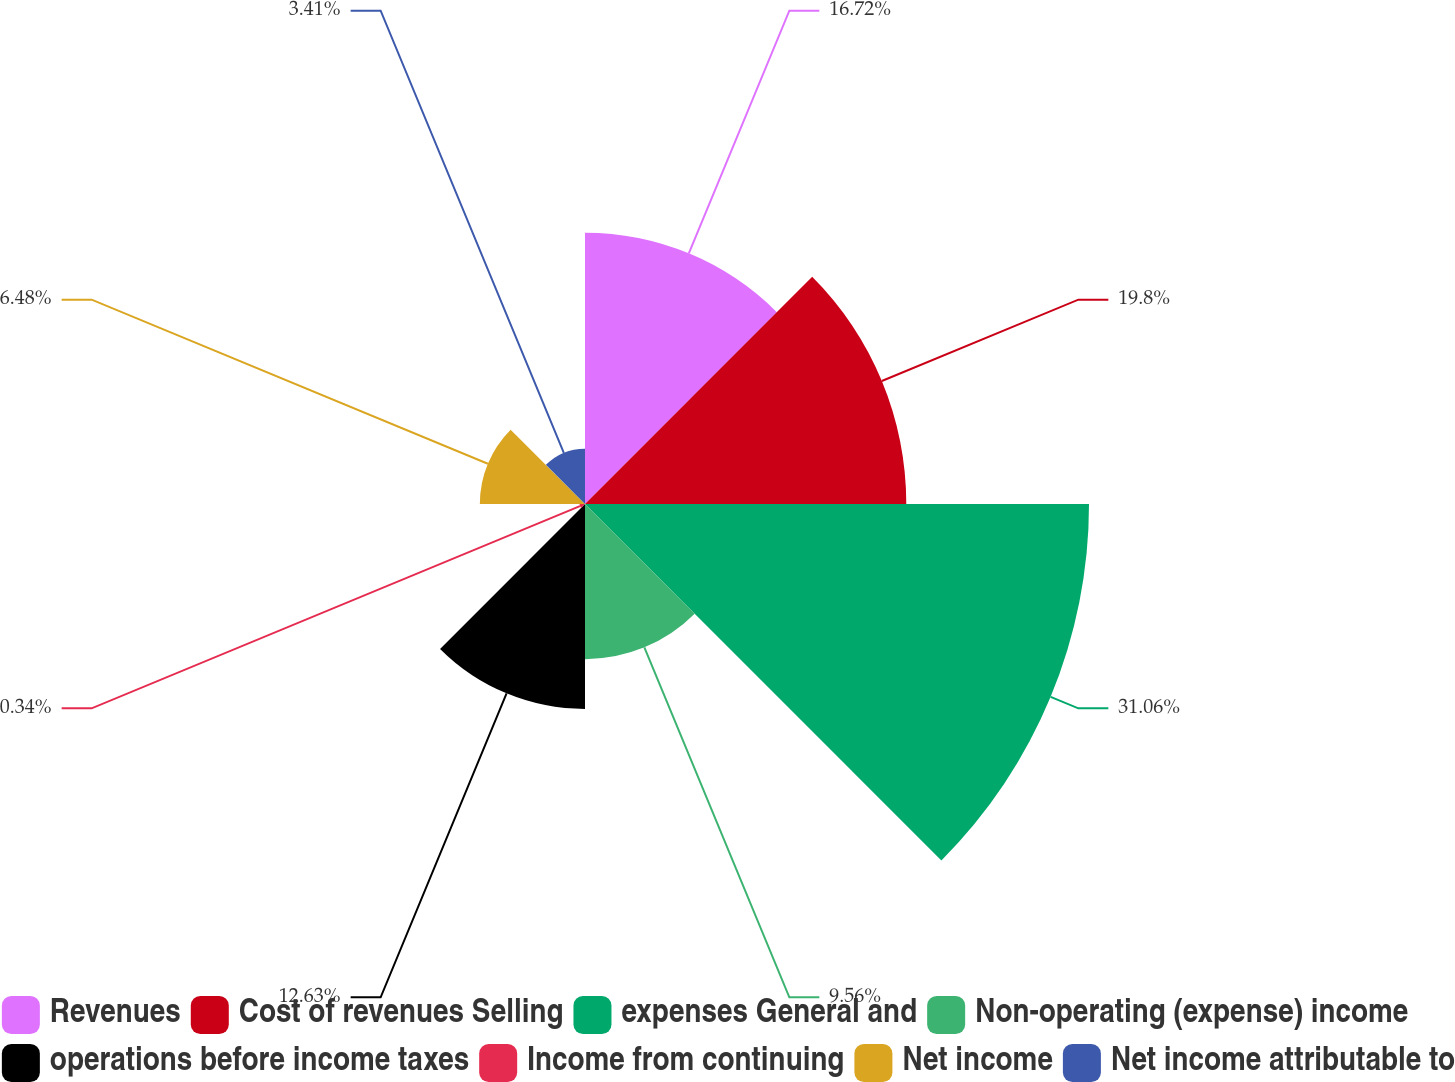<chart> <loc_0><loc_0><loc_500><loc_500><pie_chart><fcel>Revenues<fcel>Cost of revenues Selling<fcel>expenses General and<fcel>Non-operating (expense) income<fcel>operations before income taxes<fcel>Income from continuing<fcel>Net income<fcel>Net income attributable to<nl><fcel>16.72%<fcel>19.8%<fcel>31.06%<fcel>9.56%<fcel>12.63%<fcel>0.34%<fcel>6.48%<fcel>3.41%<nl></chart> 